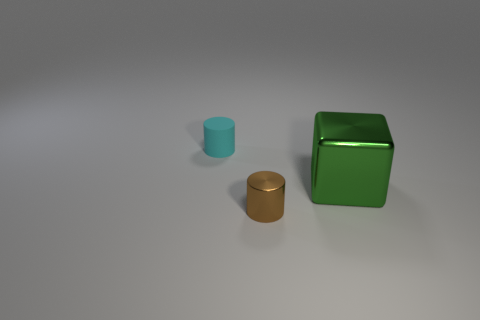Is there anything else that has the same size as the green shiny thing?
Provide a succinct answer. No. Is there any other thing that is made of the same material as the tiny cyan thing?
Provide a short and direct response. No. Is the number of cyan cylinders that are in front of the block the same as the number of tiny red rubber objects?
Your answer should be very brief. Yes. There is a shiny object that is behind the small brown metal object; what size is it?
Provide a short and direct response. Large. How many small objects are metallic cylinders or gray cubes?
Keep it short and to the point. 1. There is another small object that is the same shape as the small cyan rubber object; what is its color?
Give a very brief answer. Brown. Does the cyan cylinder have the same size as the brown cylinder?
Provide a succinct answer. Yes. What number of things are brown metallic things or objects that are behind the brown thing?
Give a very brief answer. 3. The tiny object left of the tiny object that is on the right side of the cyan matte cylinder is what color?
Give a very brief answer. Cyan. What is the material of the small thing to the right of the small cyan object?
Ensure brevity in your answer.  Metal. 